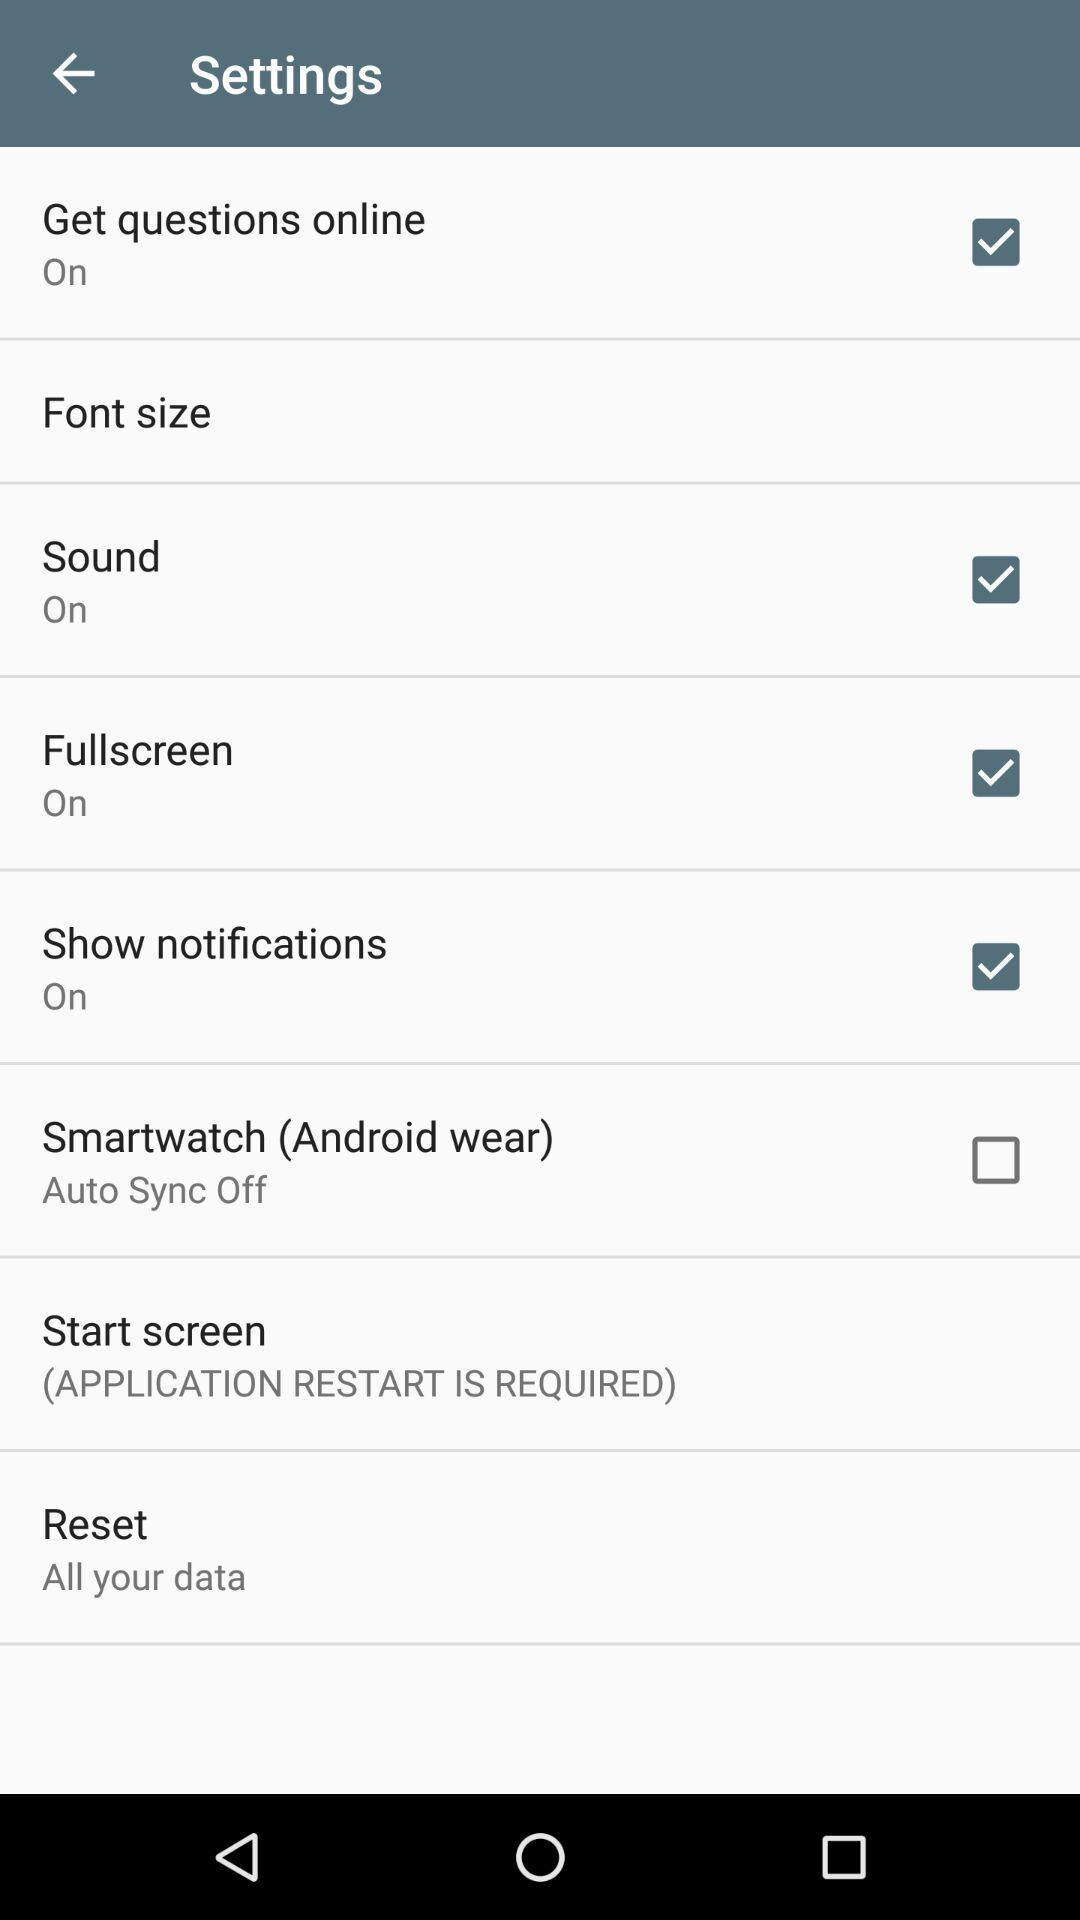What is the current status of "Show notifications"? The current status of "Show notifications" is "on". 